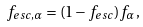<formula> <loc_0><loc_0><loc_500><loc_500>f _ { e s c , \alpha } = ( 1 - f _ { e s c } ) f _ { \alpha } ,</formula> 